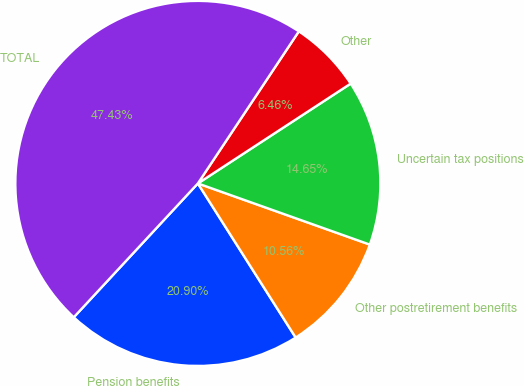<chart> <loc_0><loc_0><loc_500><loc_500><pie_chart><fcel>Pension benefits<fcel>Other postretirement benefits<fcel>Uncertain tax positions<fcel>Other<fcel>TOTAL<nl><fcel>20.9%<fcel>10.56%<fcel>14.65%<fcel>6.46%<fcel>47.43%<nl></chart> 